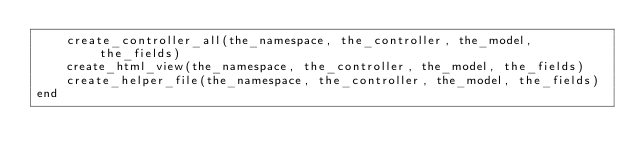<code> <loc_0><loc_0><loc_500><loc_500><_Ruby_>    create_controller_all(the_namespace, the_controller, the_model, the_fields)
    create_html_view(the_namespace, the_controller, the_model, the_fields)
    create_helper_file(the_namespace, the_controller, the_model, the_fields)
end
</code> 